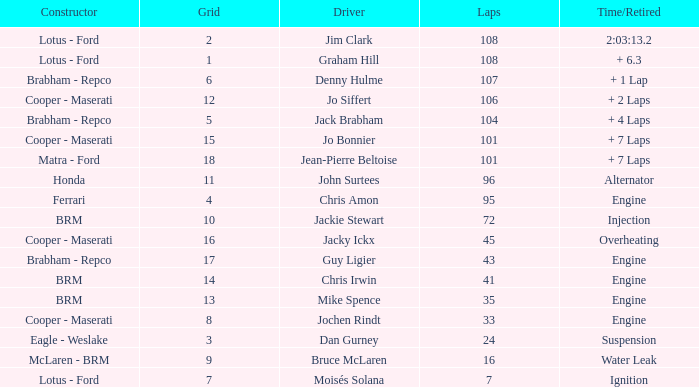What was the grid for suspension time/retired? 3.0. 